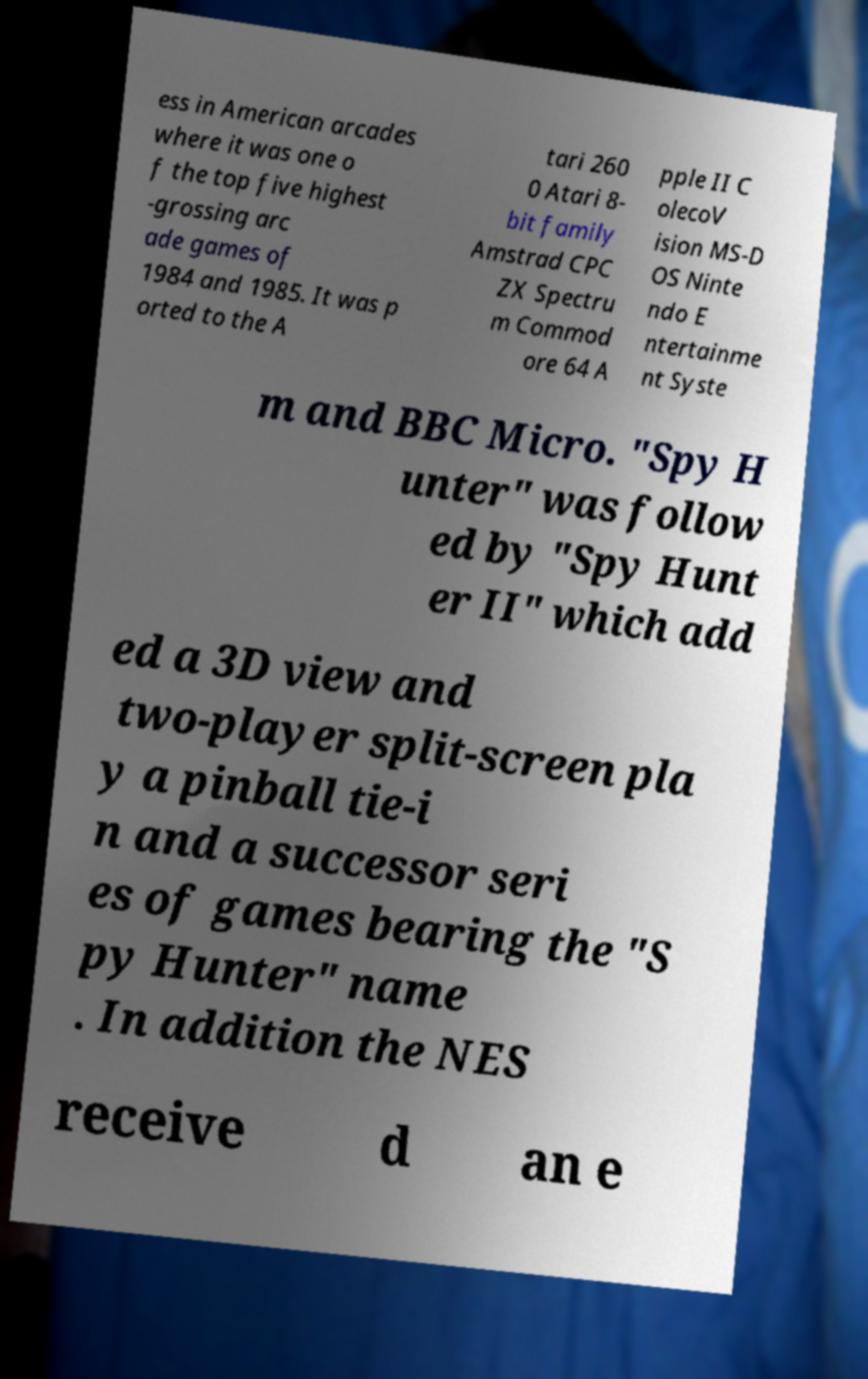Please identify and transcribe the text found in this image. ess in American arcades where it was one o f the top five highest -grossing arc ade games of 1984 and 1985. It was p orted to the A tari 260 0 Atari 8- bit family Amstrad CPC ZX Spectru m Commod ore 64 A pple II C olecoV ision MS-D OS Ninte ndo E ntertainme nt Syste m and BBC Micro. "Spy H unter" was follow ed by "Spy Hunt er II" which add ed a 3D view and two-player split-screen pla y a pinball tie-i n and a successor seri es of games bearing the "S py Hunter" name . In addition the NES receive d an e 